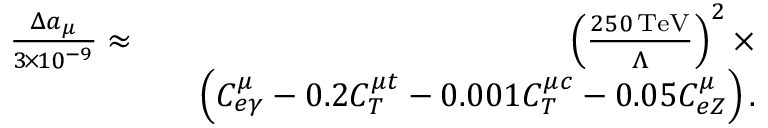Convert formula to latex. <formula><loc_0><loc_0><loc_500><loc_500>\begin{array} { r l r } { \frac { \Delta a _ { \mu } } { 3 \, \times \, 1 0 ^ { - 9 } } \approx } & { \left ( \frac { 2 5 0 \, T e V } { \Lambda } \right ) ^ { 2 } \times } \\ & { \left ( C _ { e \gamma } ^ { \mu } - 0 . 2 C _ { T } ^ { \mu t } - 0 . 0 0 1 C _ { T } ^ { \mu c } - 0 . 0 5 C _ { e Z } ^ { \mu } \right ) . } \end{array}</formula> 